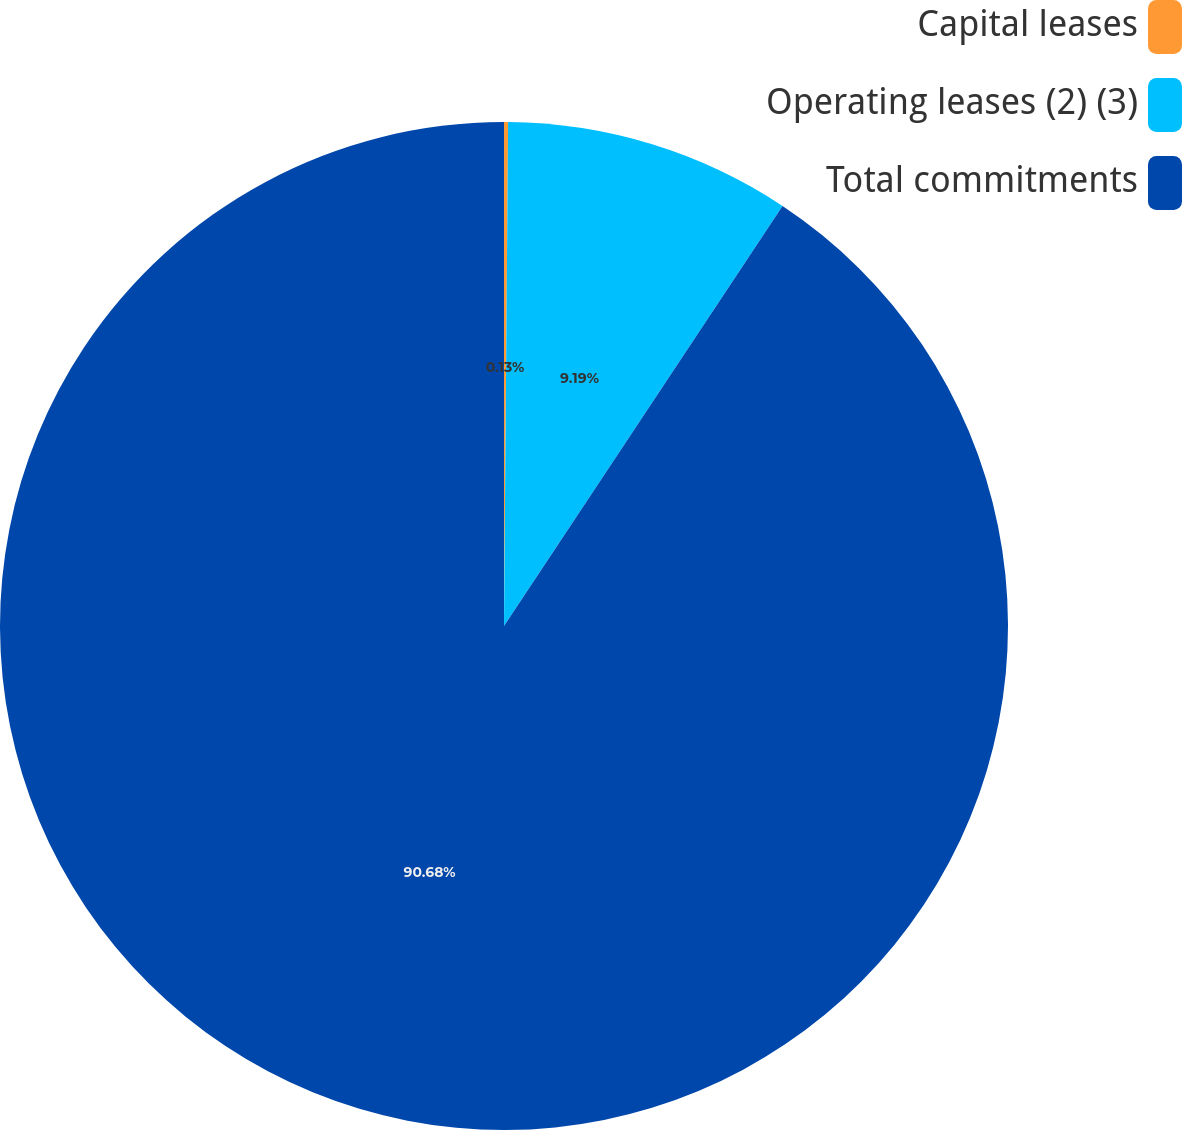<chart> <loc_0><loc_0><loc_500><loc_500><pie_chart><fcel>Capital leases<fcel>Operating leases (2) (3)<fcel>Total commitments<nl><fcel>0.13%<fcel>9.19%<fcel>90.68%<nl></chart> 